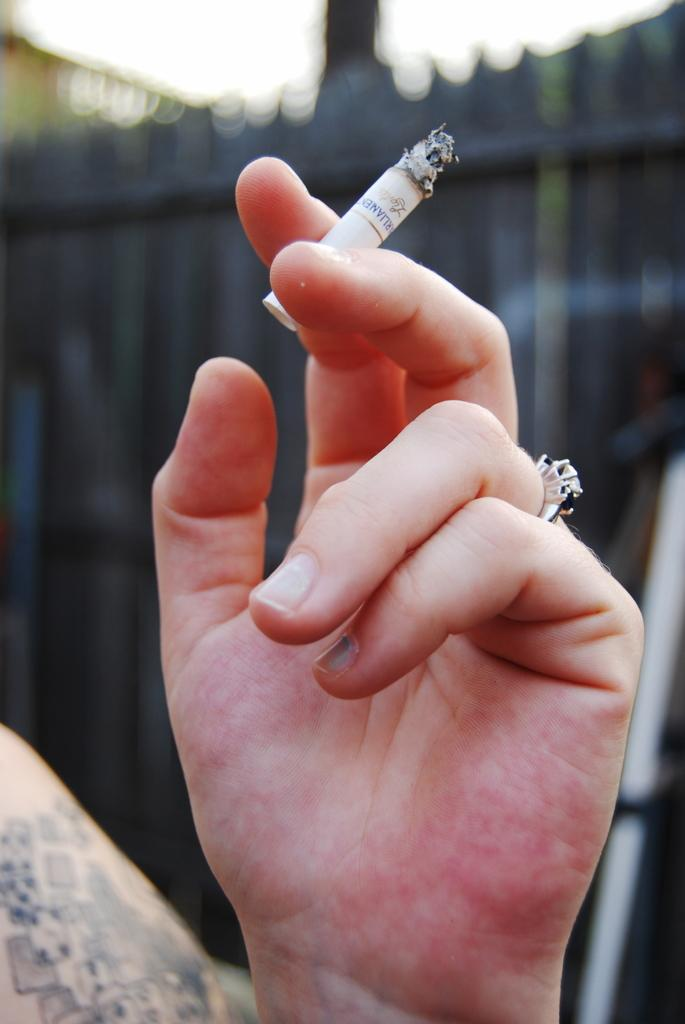What can be seen in the image that belongs to a person? There is a hand of a person in the image. What is the hand holding? The hand is holding a cigarette. Can you describe the background of the image? The background of the image is blurred. How many cars are parked in the background of the image? There are no cars visible in the image, as the background is blurred. What type of celery is being used as a prop in the image? There is no celery present in the image. 